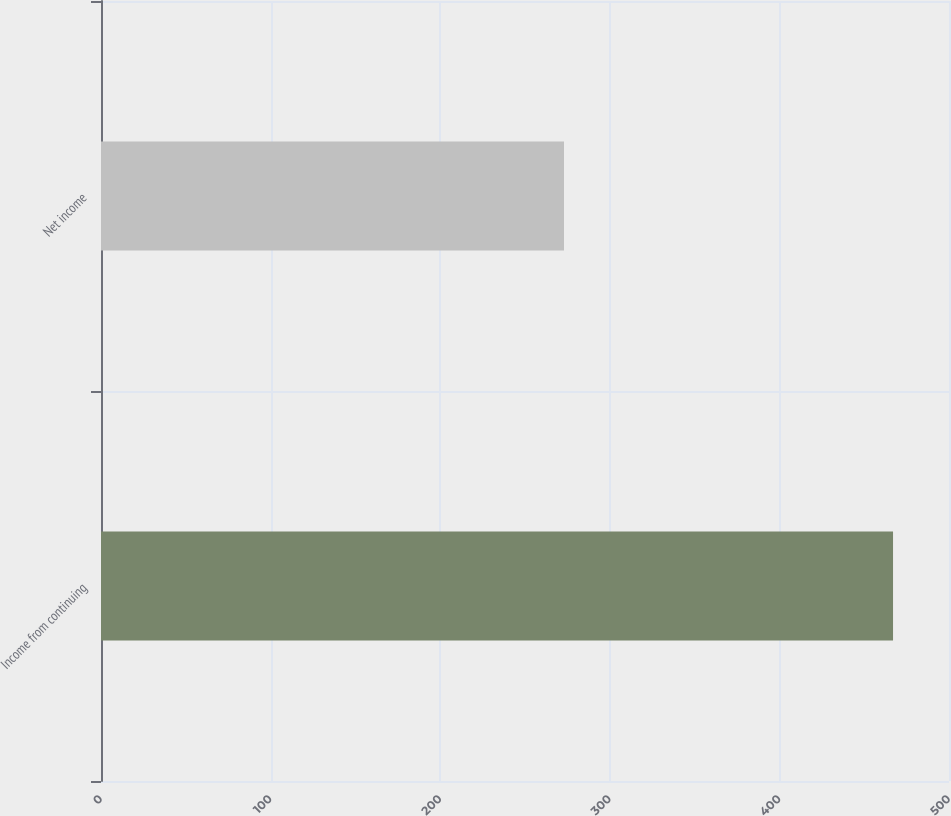Convert chart to OTSL. <chart><loc_0><loc_0><loc_500><loc_500><bar_chart><fcel>Income from continuing<fcel>Net income<nl><fcel>467<fcel>273<nl></chart> 